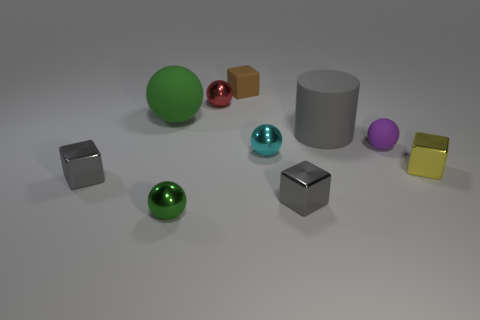Subtract all brown blocks. How many green spheres are left? 2 Subtract all green rubber balls. How many balls are left? 4 Subtract all cyan spheres. How many spheres are left? 4 Subtract 1 balls. How many balls are left? 4 Subtract all yellow blocks. Subtract all brown balls. How many blocks are left? 3 Subtract 0 purple cubes. How many objects are left? 10 Subtract all blocks. How many objects are left? 6 Subtract all gray matte objects. Subtract all green metal spheres. How many objects are left? 8 Add 8 small brown things. How many small brown things are left? 9 Add 2 tiny yellow metal cylinders. How many tiny yellow metal cylinders exist? 2 